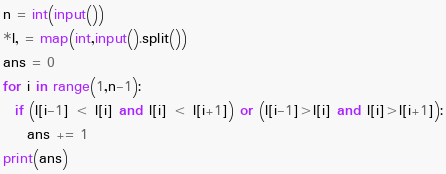Convert code to text. <code><loc_0><loc_0><loc_500><loc_500><_Python_>n = int(input())
*l, = map(int,input().split())
ans = 0
for i in range(1,n-1):
  if (l[i-1] < l[i] and l[i] < l[i+1]) or (l[i-1]>l[i] and l[i]>l[i+1]):
    ans += 1
print(ans)</code> 